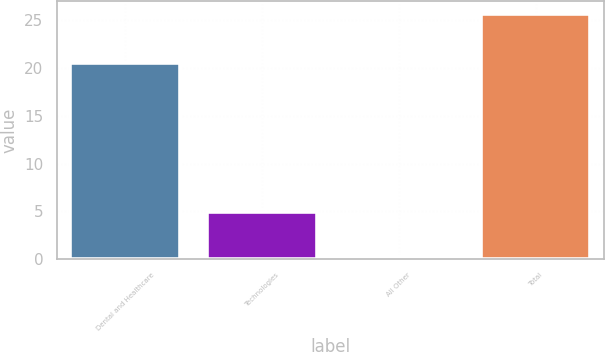Convert chart. <chart><loc_0><loc_0><loc_500><loc_500><bar_chart><fcel>Dental and Healthcare<fcel>Technologies<fcel>All Other<fcel>Total<nl><fcel>20.5<fcel>4.9<fcel>0.3<fcel>25.7<nl></chart> 